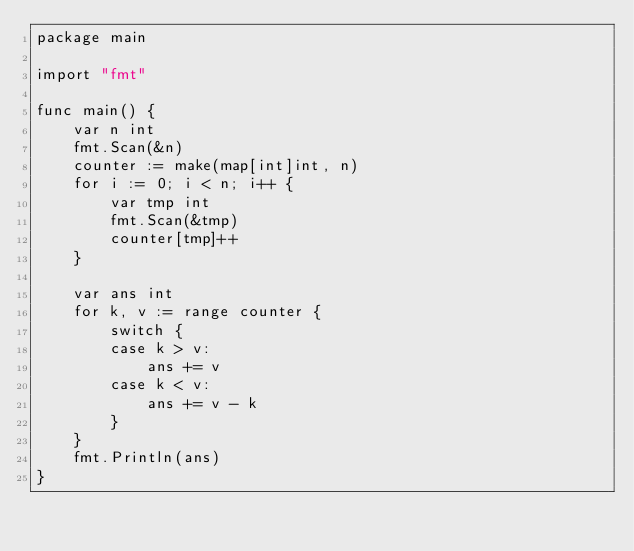Convert code to text. <code><loc_0><loc_0><loc_500><loc_500><_Go_>package main

import "fmt"

func main() {
	var n int
	fmt.Scan(&n)
	counter := make(map[int]int, n)
	for i := 0; i < n; i++ {
		var tmp int
		fmt.Scan(&tmp)
		counter[tmp]++
	}

	var ans int
	for k, v := range counter {
		switch {
		case k > v:
			ans += v
		case k < v:
			ans += v - k
		}
	}
	fmt.Println(ans)
}
</code> 